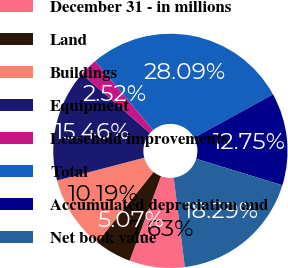Convert chart to OTSL. <chart><loc_0><loc_0><loc_500><loc_500><pie_chart><fcel>December 31 - in millions<fcel>Land<fcel>Buildings<fcel>Equipment<fcel>Leasehold improvements<fcel>Total<fcel>Accumulated depreciation and<fcel>Net book value<nl><fcel>7.63%<fcel>5.07%<fcel>10.19%<fcel>15.46%<fcel>2.52%<fcel>28.09%<fcel>12.75%<fcel>18.29%<nl></chart> 